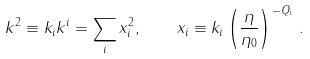<formula> <loc_0><loc_0><loc_500><loc_500>k ^ { 2 } \equiv k _ { i } k ^ { i } = \sum _ { i } x _ { i } ^ { 2 } , \quad x _ { i } \equiv k _ { i } \left ( \frac { \eta } { \eta _ { 0 } } \right ) ^ { - Q _ { i } } \, .</formula> 